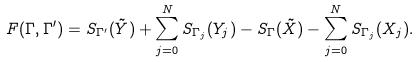Convert formula to latex. <formula><loc_0><loc_0><loc_500><loc_500>F ( \Gamma , \Gamma ^ { \prime } ) = S _ { \Gamma ^ { \prime } } ( \tilde { Y } ) + \sum _ { j = 0 } ^ { N } S _ { \Gamma _ { j } } ( Y _ { j } ) - S _ { \Gamma } ( \tilde { X } ) - \sum _ { j = 0 } ^ { N } S _ { \Gamma _ { j } } ( X _ { j } ) .</formula> 